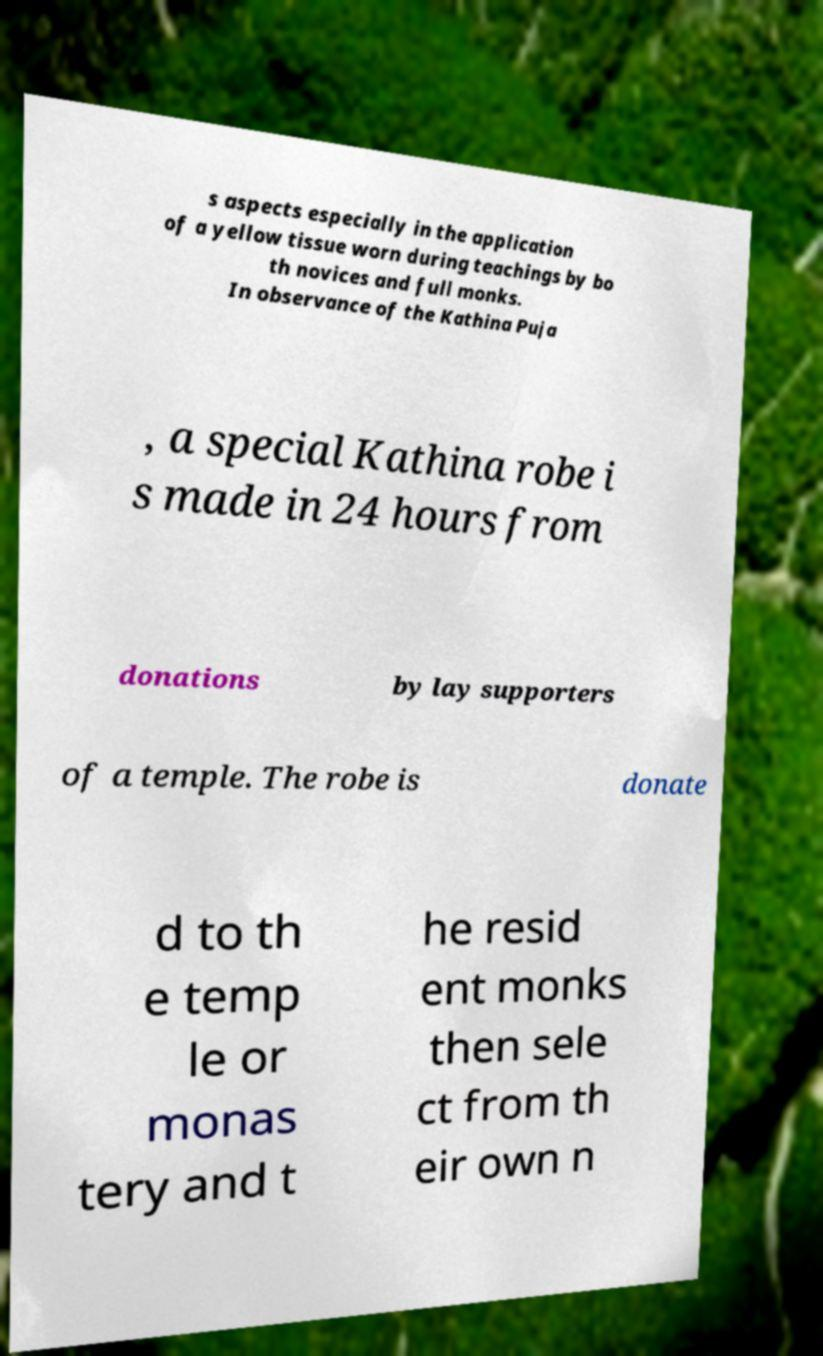Can you read and provide the text displayed in the image?This photo seems to have some interesting text. Can you extract and type it out for me? s aspects especially in the application of a yellow tissue worn during teachings by bo th novices and full monks. In observance of the Kathina Puja , a special Kathina robe i s made in 24 hours from donations by lay supporters of a temple. The robe is donate d to th e temp le or monas tery and t he resid ent monks then sele ct from th eir own n 